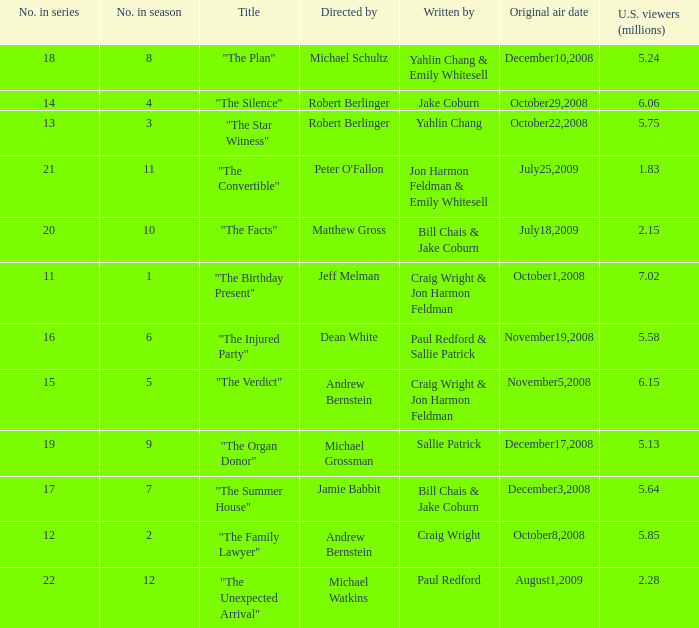What is the original air date of the episode directed by Jeff Melman? October1,2008. 